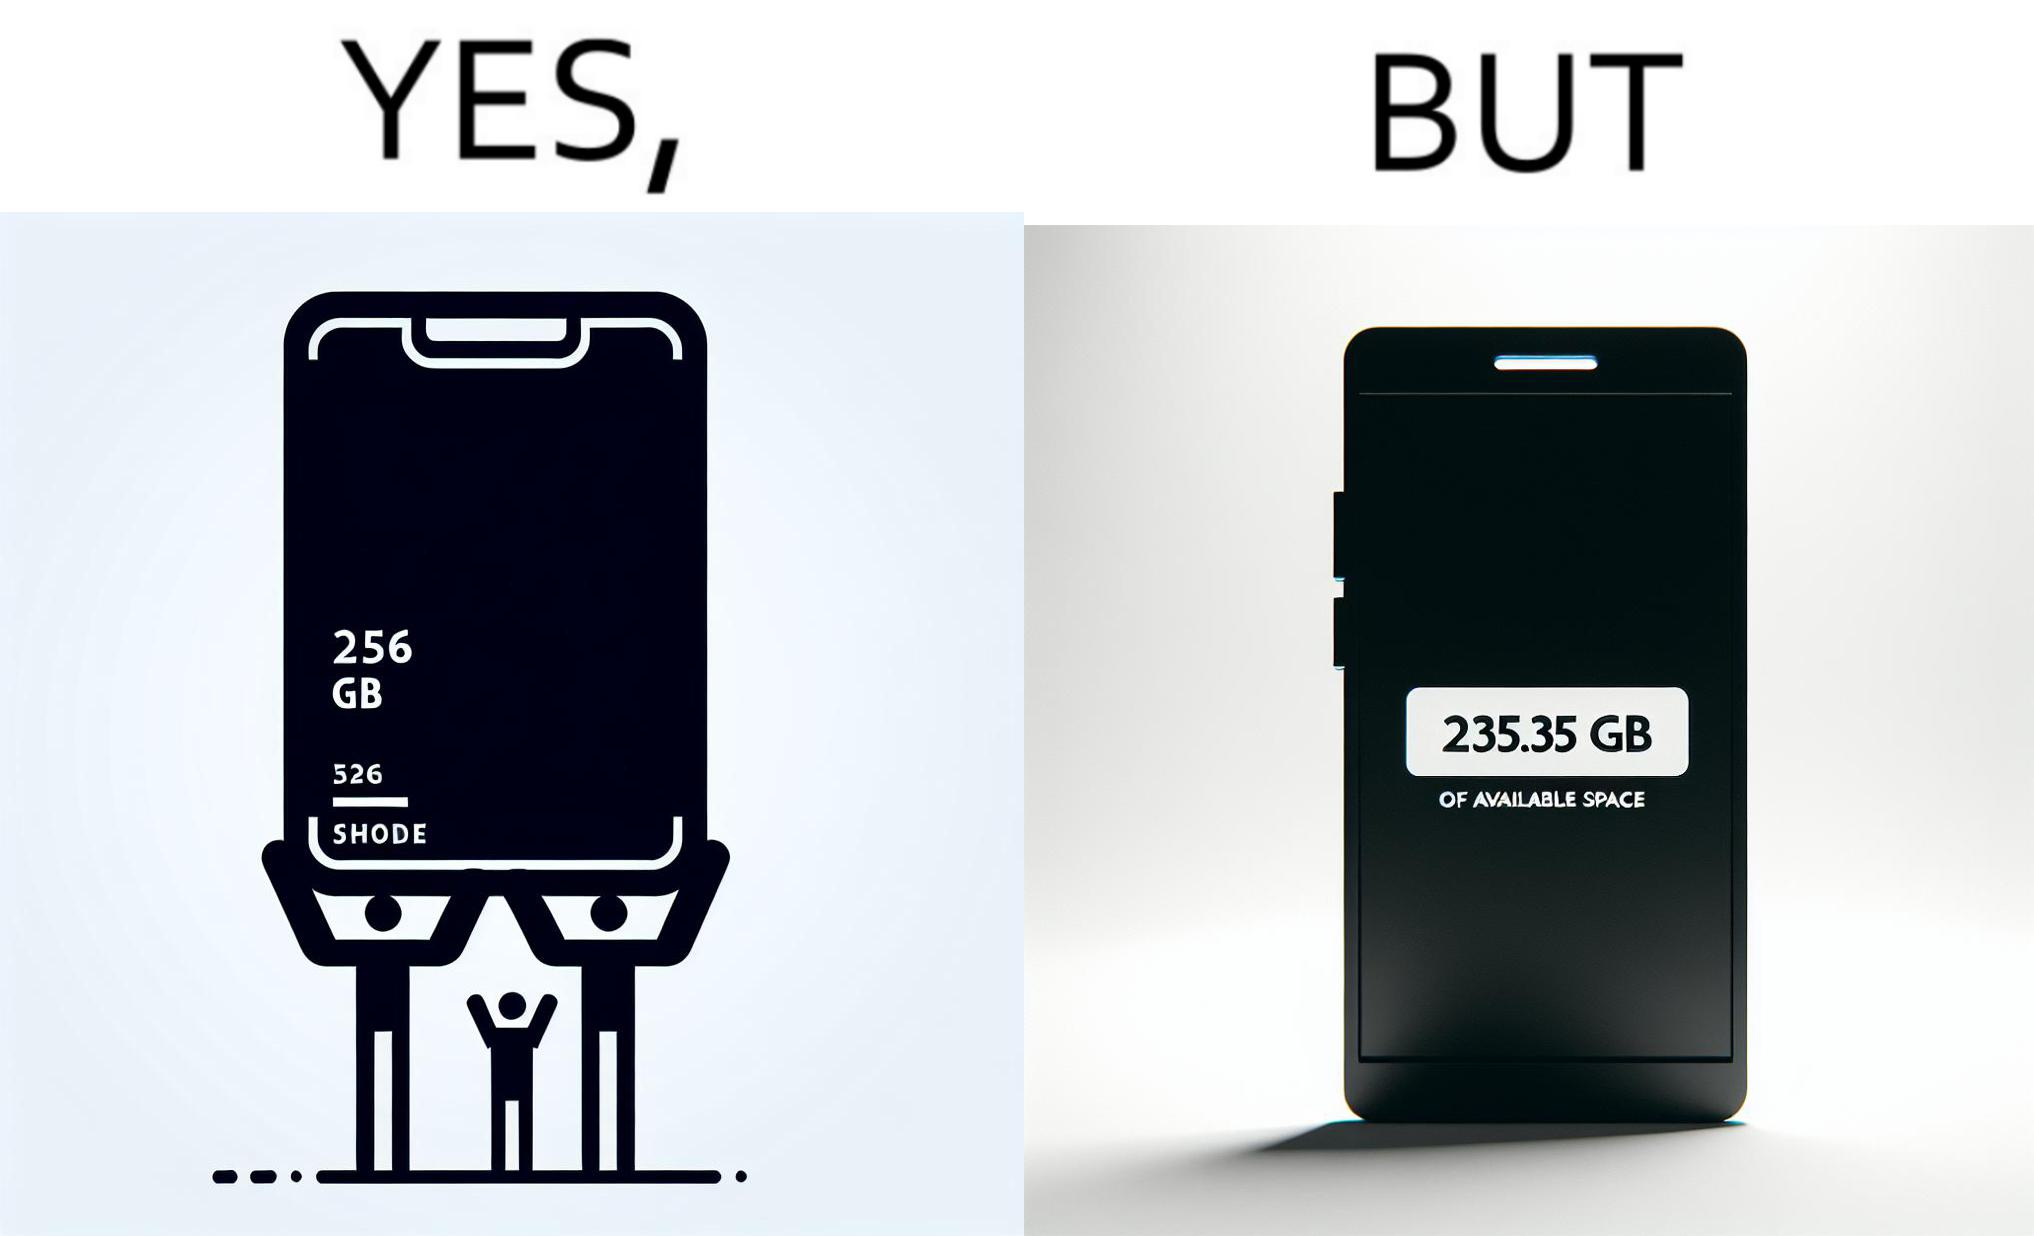Would you classify this image as satirical? Yes, this image is satirical. 